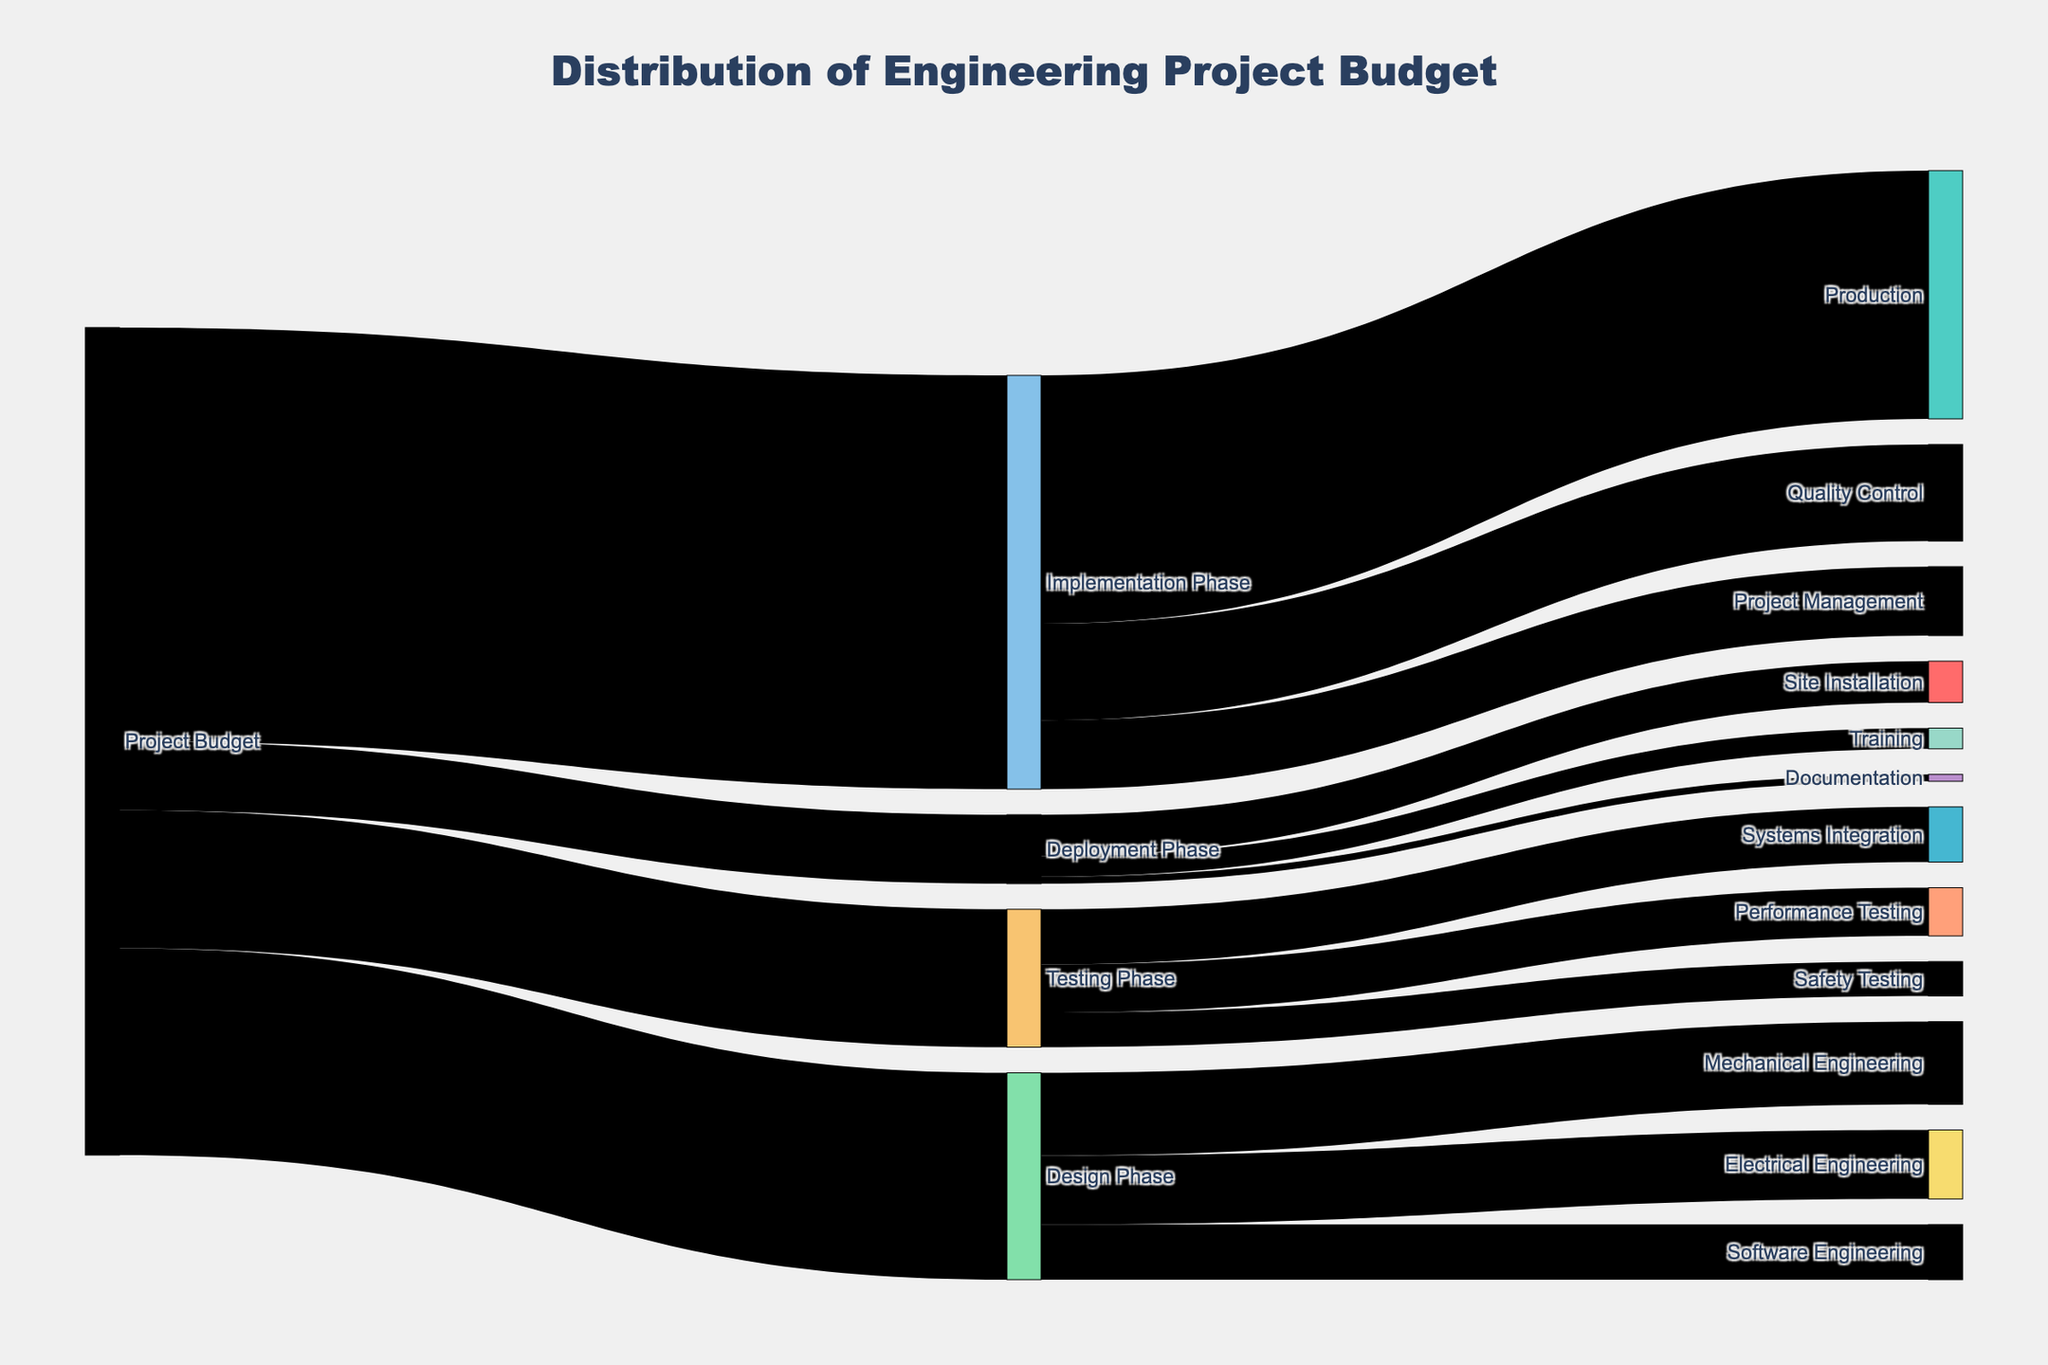What is the total budget allocated to the Design Phase? The Design Phase has links from the Project Budget with values, adding up to 1,500,000. The detailed breakdown into Mechanical, Electrical, and Software Engineering matches the total.
Answer: 1,500,000 Which phase receives the largest portion of the project budget? Comparing the values from Project Budget to each phase: Design (1,500,000), Implementation (3,000,000), Testing (1,000,000), Deployment (500,000), Implementation receives the largest portion.
Answer: Implementation Phase How much budget is allocated to Mechanical Engineering? Mechanical Engineering is part of the Design Phase with a 600,000 allocation. This is visually visible as an outgoing link from the Design Phase.
Answer: 600,000 What is the difference between the budget allocated to Production and Quality Control in the Implementation Phase? Production has 1,800,000, and Quality Control has 700,000. The difference is 1,800,000 - 700,000 = 1,100,000.
Answer: 1,100,000 What's the combined budget for all Testing Phase activities? The Testing Phase activities are Systems Integration (400,000), Performance Testing (350,000), and Safety Testing (250,000). Adding these up gives 400,000 + 350,000 + 250,000 = 1,000,000.
Answer: 1,000,000 Which department in the Deployment Phase has the smallest budget, and how much is it? The Deployment Phase budgets are for Site Installation (300,000), Training (150,000), and Documentation (50,000). Documentation has the smallest budget, with 50,000.
Answer: Documentation, 50,000 Compare the budget allocation between Project Management in the Implementation Phase and Training in the Deployment Phase. Which has a higher value? Project Management has 500,000, while Training has 150,000. Project Management has a higher value.
Answer: Project Management What is the total project budget as visualized in the diagram? Summing all phase allocations from the Project Budget: Design (1,500,000), Implementation (3,000,000), Testing (1,000,000), Deployment (500,000), we get 1,500,000 + 3,000,000 + 1,000,000 + 500,000 = 6,000,000.
Answer: 6,000,000 